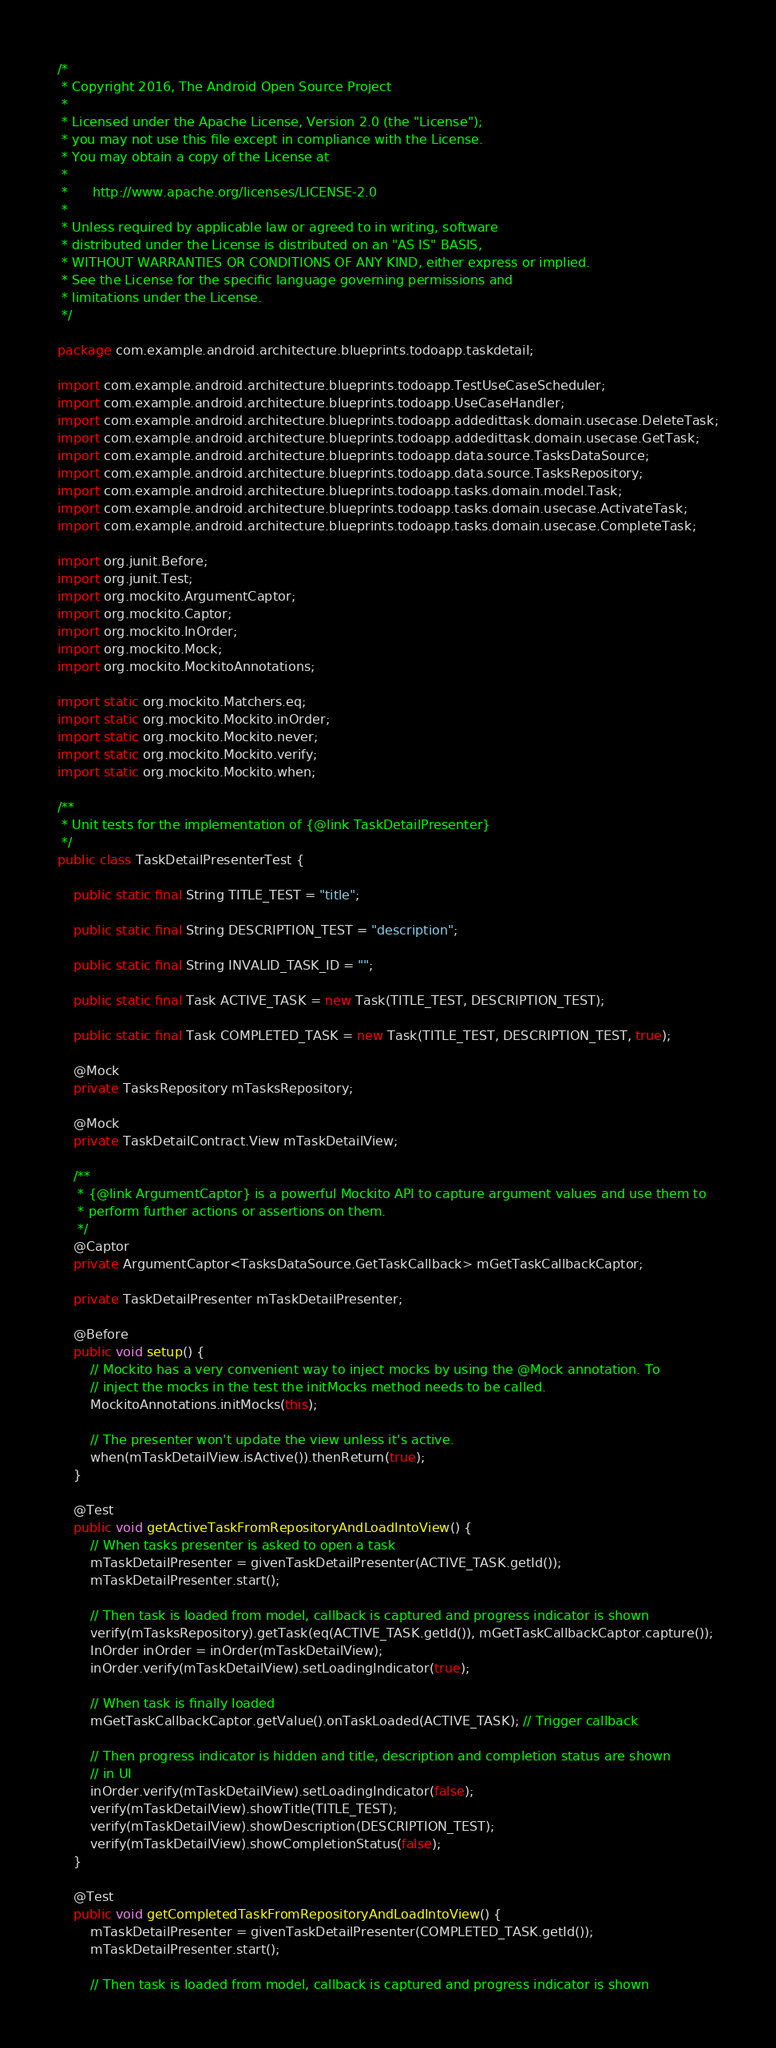Convert code to text. <code><loc_0><loc_0><loc_500><loc_500><_Java_>/*
 * Copyright 2016, The Android Open Source Project
 *
 * Licensed under the Apache License, Version 2.0 (the "License");
 * you may not use this file except in compliance with the License.
 * You may obtain a copy of the License at
 *
 *      http://www.apache.org/licenses/LICENSE-2.0
 *
 * Unless required by applicable law or agreed to in writing, software
 * distributed under the License is distributed on an "AS IS" BASIS,
 * WITHOUT WARRANTIES OR CONDITIONS OF ANY KIND, either express or implied.
 * See the License for the specific language governing permissions and
 * limitations under the License.
 */

package com.example.android.architecture.blueprints.todoapp.taskdetail;

import com.example.android.architecture.blueprints.todoapp.TestUseCaseScheduler;
import com.example.android.architecture.blueprints.todoapp.UseCaseHandler;
import com.example.android.architecture.blueprints.todoapp.addedittask.domain.usecase.DeleteTask;
import com.example.android.architecture.blueprints.todoapp.addedittask.domain.usecase.GetTask;
import com.example.android.architecture.blueprints.todoapp.data.source.TasksDataSource;
import com.example.android.architecture.blueprints.todoapp.data.source.TasksRepository;
import com.example.android.architecture.blueprints.todoapp.tasks.domain.model.Task;
import com.example.android.architecture.blueprints.todoapp.tasks.domain.usecase.ActivateTask;
import com.example.android.architecture.blueprints.todoapp.tasks.domain.usecase.CompleteTask;

import org.junit.Before;
import org.junit.Test;
import org.mockito.ArgumentCaptor;
import org.mockito.Captor;
import org.mockito.InOrder;
import org.mockito.Mock;
import org.mockito.MockitoAnnotations;

import static org.mockito.Matchers.eq;
import static org.mockito.Mockito.inOrder;
import static org.mockito.Mockito.never;
import static org.mockito.Mockito.verify;
import static org.mockito.Mockito.when;

/**
 * Unit tests for the implementation of {@link TaskDetailPresenter}
 */
public class TaskDetailPresenterTest {

    public static final String TITLE_TEST = "title";

    public static final String DESCRIPTION_TEST = "description";

    public static final String INVALID_TASK_ID = "";

    public static final Task ACTIVE_TASK = new Task(TITLE_TEST, DESCRIPTION_TEST);

    public static final Task COMPLETED_TASK = new Task(TITLE_TEST, DESCRIPTION_TEST, true);

    @Mock
    private TasksRepository mTasksRepository;

    @Mock
    private TaskDetailContract.View mTaskDetailView;

    /**
     * {@link ArgumentCaptor} is a powerful Mockito API to capture argument values and use them to
     * perform further actions or assertions on them.
     */
    @Captor
    private ArgumentCaptor<TasksDataSource.GetTaskCallback> mGetTaskCallbackCaptor;

    private TaskDetailPresenter mTaskDetailPresenter;

    @Before
    public void setup() {
        // Mockito has a very convenient way to inject mocks by using the @Mock annotation. To
        // inject the mocks in the test the initMocks method needs to be called.
        MockitoAnnotations.initMocks(this);

        // The presenter won't update the view unless it's active.
        when(mTaskDetailView.isActive()).thenReturn(true);
    }

    @Test
    public void getActiveTaskFromRepositoryAndLoadIntoView() {
        // When tasks presenter is asked to open a task
        mTaskDetailPresenter = givenTaskDetailPresenter(ACTIVE_TASK.getId());
        mTaskDetailPresenter.start();

        // Then task is loaded from model, callback is captured and progress indicator is shown
        verify(mTasksRepository).getTask(eq(ACTIVE_TASK.getId()), mGetTaskCallbackCaptor.capture());
        InOrder inOrder = inOrder(mTaskDetailView);
        inOrder.verify(mTaskDetailView).setLoadingIndicator(true);

        // When task is finally loaded
        mGetTaskCallbackCaptor.getValue().onTaskLoaded(ACTIVE_TASK); // Trigger callback

        // Then progress indicator is hidden and title, description and completion status are shown
        // in UI
        inOrder.verify(mTaskDetailView).setLoadingIndicator(false);
        verify(mTaskDetailView).showTitle(TITLE_TEST);
        verify(mTaskDetailView).showDescription(DESCRIPTION_TEST);
        verify(mTaskDetailView).showCompletionStatus(false);
    }

    @Test
    public void getCompletedTaskFromRepositoryAndLoadIntoView() {
        mTaskDetailPresenter = givenTaskDetailPresenter(COMPLETED_TASK.getId());
        mTaskDetailPresenter.start();

        // Then task is loaded from model, callback is captured and progress indicator is shown</code> 